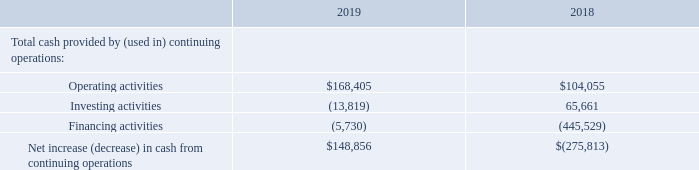The table below summarizes our cash flows from continuing operations activities for each of the last two fiscal years (in thousands):
Operating Activities. Operating cash flows increased $64.4 million in 2019 compared with 2018 primarily due to favorable changes in working capital of  $37.0 million, primarily due to lower income tax payments of$41.3 million, and higher net income adjusted for non-cash items of $27.3 million
Pension and Postretirement Contributions — Our policy is to fund our pension plans at or above the minimum required by law. As of January 1, 2019, the date of our last actuarial funding valuation for our qualified pension plan, there was no minimum contribution funding requirement. In 2019 and 2018, we contributed $6.2 million and $5.5 million, respectively, to our pension and postretirement plans. We do not anticipate making any contributions to our qualified defined benefit pension plan in fiscal 2020. For additional information, refer to Note 12, Retirement Plans, of the notes to the consolidated financial statements.
How much did operating cash flows increased by from 2018 to 2019? $64.4 million. How much money was contributed to the pension and postretirement plan in 2019? $6.2 million. How much money was contributed to the pension and postretirement plan in 2018? $5.5 million. What is the average of the cash flows for operating activities for 2018 and 2019?
Answer scale should be: thousand. ($168,405 + $104,055)/2
Answer: 136230. What is the difference in cash flows for investing activities between 2018 and 2019?
Answer scale should be: thousand. $65,661 + $13,819 
Answer: 79480. What is the percentage change in cash flows from operating activities from 2018 to 2019?
Answer scale should be: percent. ($168,405 - $104,055)/$104,055 
Answer: 61.84. 